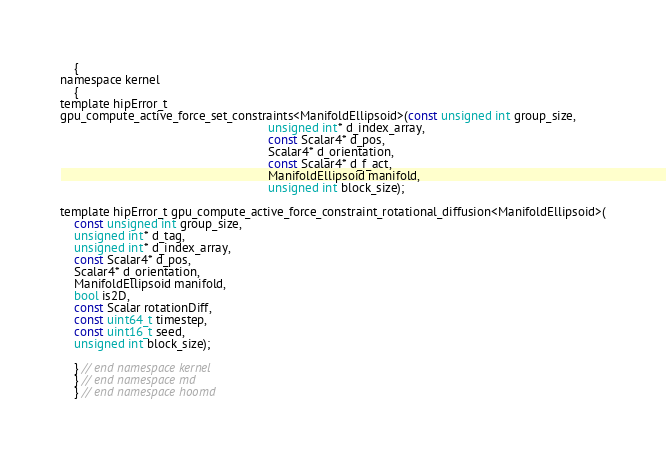<code> <loc_0><loc_0><loc_500><loc_500><_Cuda_>    {
namespace kernel
    {
template hipError_t
gpu_compute_active_force_set_constraints<ManifoldEllipsoid>(const unsigned int group_size,
                                                            unsigned int* d_index_array,
                                                            const Scalar4* d_pos,
                                                            Scalar4* d_orientation,
                                                            const Scalar4* d_f_act,
                                                            ManifoldEllipsoid manifold,
                                                            unsigned int block_size);

template hipError_t gpu_compute_active_force_constraint_rotational_diffusion<ManifoldEllipsoid>(
    const unsigned int group_size,
    unsigned int* d_tag,
    unsigned int* d_index_array,
    const Scalar4* d_pos,
    Scalar4* d_orientation,
    ManifoldEllipsoid manifold,
    bool is2D,
    const Scalar rotationDiff,
    const uint64_t timestep,
    const uint16_t seed,
    unsigned int block_size);

    } // end namespace kernel
    } // end namespace md
    } // end namespace hoomd
</code> 